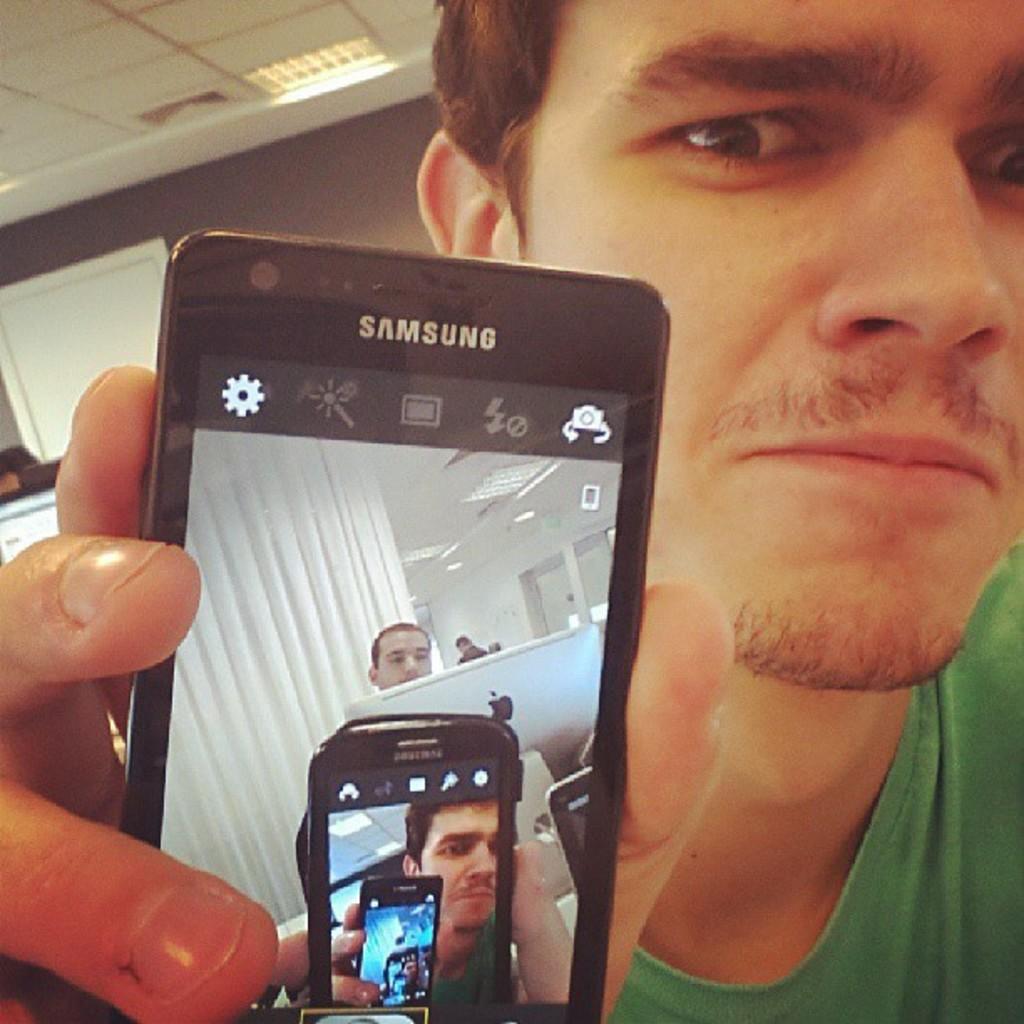How many phones are in the photo?
Offer a terse response. Answering does not require reading text in the image. 